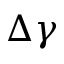Convert formula to latex. <formula><loc_0><loc_0><loc_500><loc_500>\Delta \gamma</formula> 